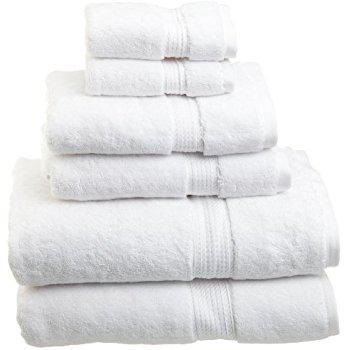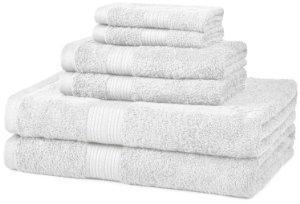The first image is the image on the left, the second image is the image on the right. For the images displayed, is the sentence "There are exactly six folded items in the image on the right." factually correct? Answer yes or no. Yes. 